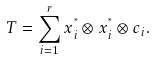Convert formula to latex. <formula><loc_0><loc_0><loc_500><loc_500>T = \sum _ { i = 1 } ^ { r } x _ { i } ^ { ^ { * } } \otimes x _ { i } ^ { ^ { * } } \otimes c _ { i } .</formula> 